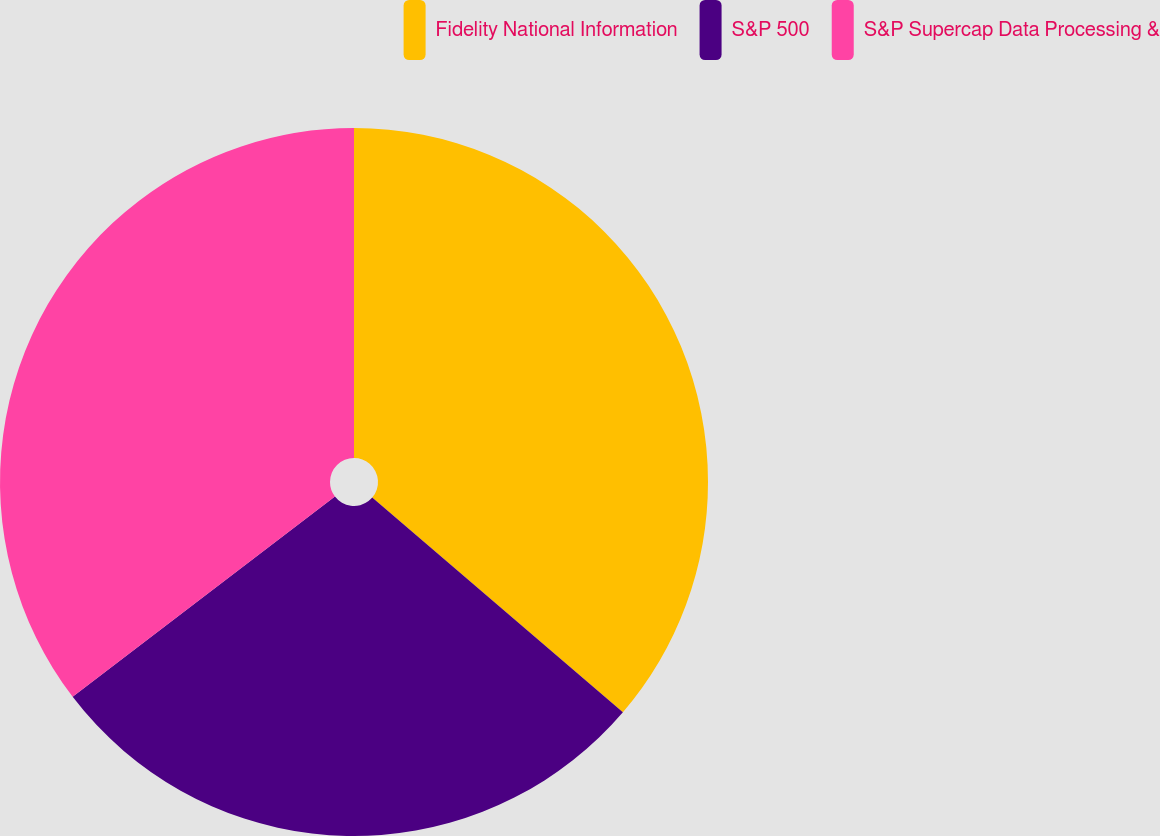Convert chart to OTSL. <chart><loc_0><loc_0><loc_500><loc_500><pie_chart><fcel>Fidelity National Information<fcel>S&P 500<fcel>S&P Supercap Data Processing &<nl><fcel>36.27%<fcel>28.35%<fcel>35.38%<nl></chart> 